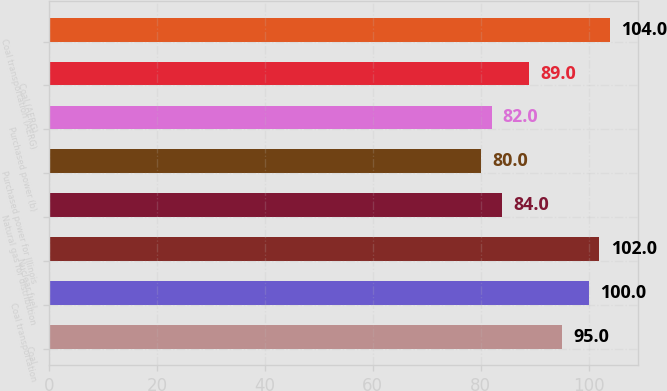Convert chart to OTSL. <chart><loc_0><loc_0><loc_500><loc_500><bar_chart><fcel>Coal<fcel>Coal transportation<fcel>Nuclear fuel<fcel>Natural gas for distribution<fcel>Purchased power for Illinois<fcel>Purchased power (b)<fcel>Coal (AERG)<fcel>Coal transportation (AERG)<nl><fcel>95<fcel>100<fcel>102<fcel>84<fcel>80<fcel>82<fcel>89<fcel>104<nl></chart> 